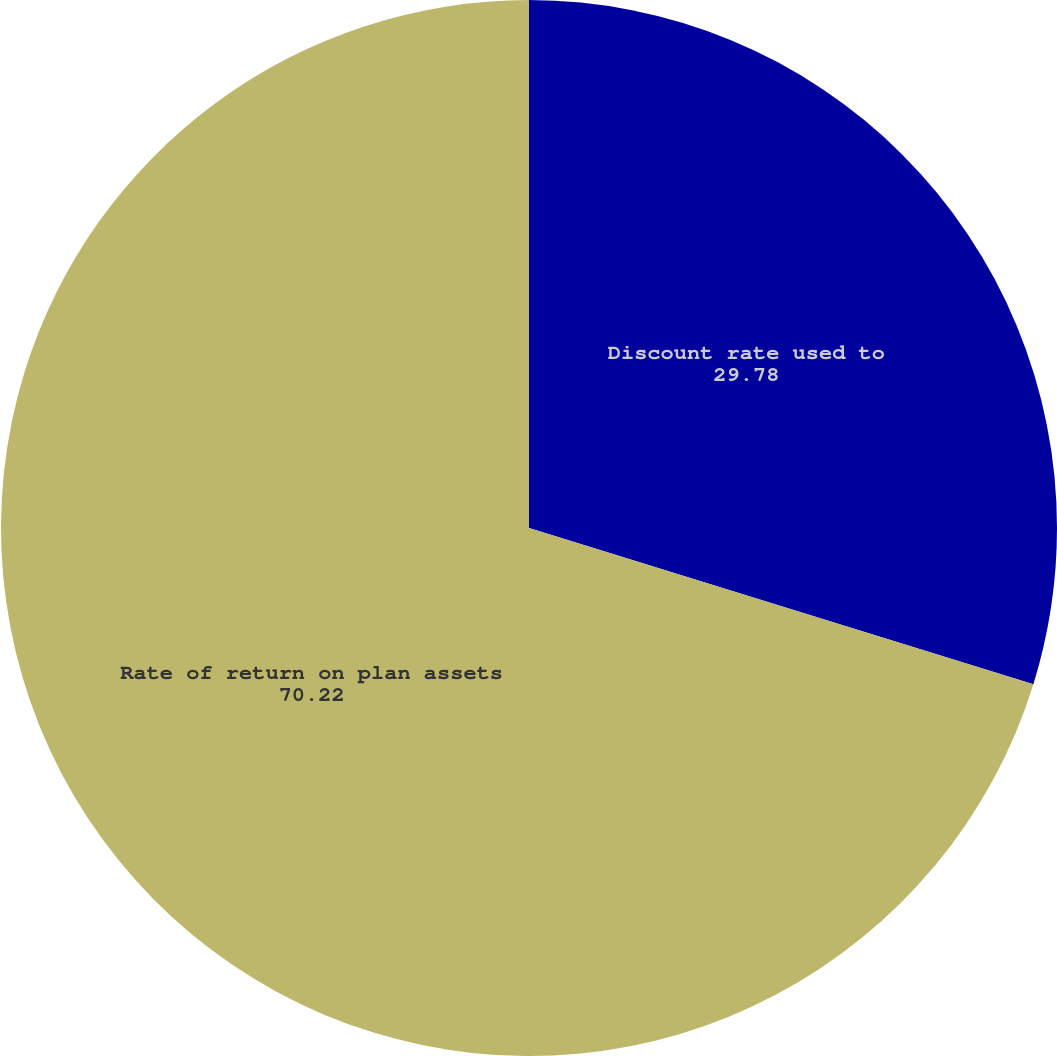Convert chart. <chart><loc_0><loc_0><loc_500><loc_500><pie_chart><fcel>Discount rate used to<fcel>Rate of return on plan assets<nl><fcel>29.78%<fcel>70.22%<nl></chart> 